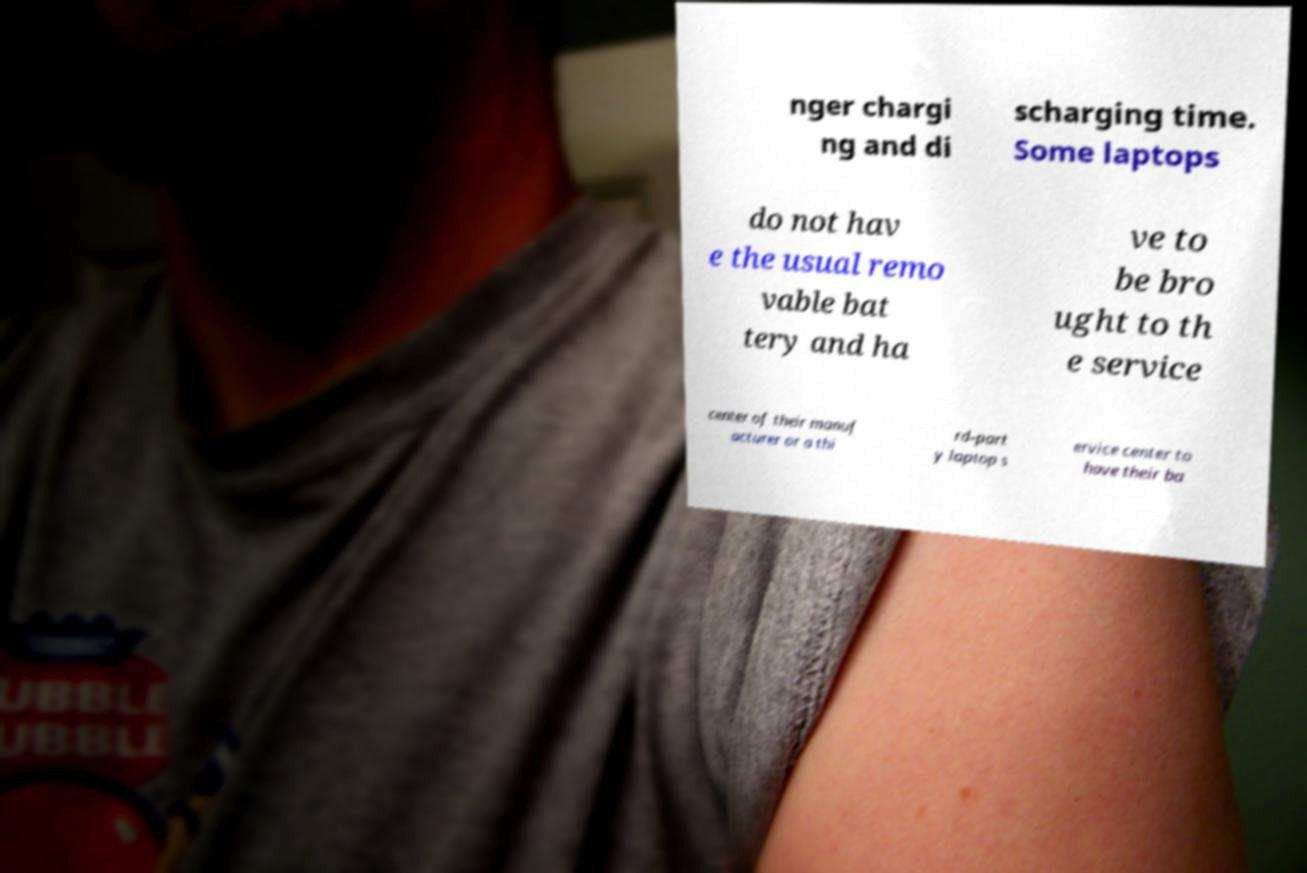Could you assist in decoding the text presented in this image and type it out clearly? nger chargi ng and di scharging time. Some laptops do not hav e the usual remo vable bat tery and ha ve to be bro ught to th e service center of their manuf acturer or a thi rd-part y laptop s ervice center to have their ba 